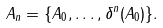Convert formula to latex. <formula><loc_0><loc_0><loc_500><loc_500>A _ { n } = \{ A _ { 0 } , \dots , \delta ^ { n } ( A _ { 0 } ) \} .</formula> 